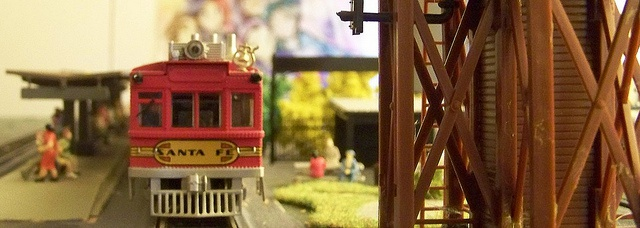Describe the objects in this image and their specific colors. I can see train in lightyellow, brown, maroon, black, and tan tones, people in lightyellow, brown, red, orange, and olive tones, people in lightyellow, olive, khaki, and darkgray tones, people in lightyellow, olive, and tan tones, and people in lightyellow, salmon, brown, and red tones in this image. 